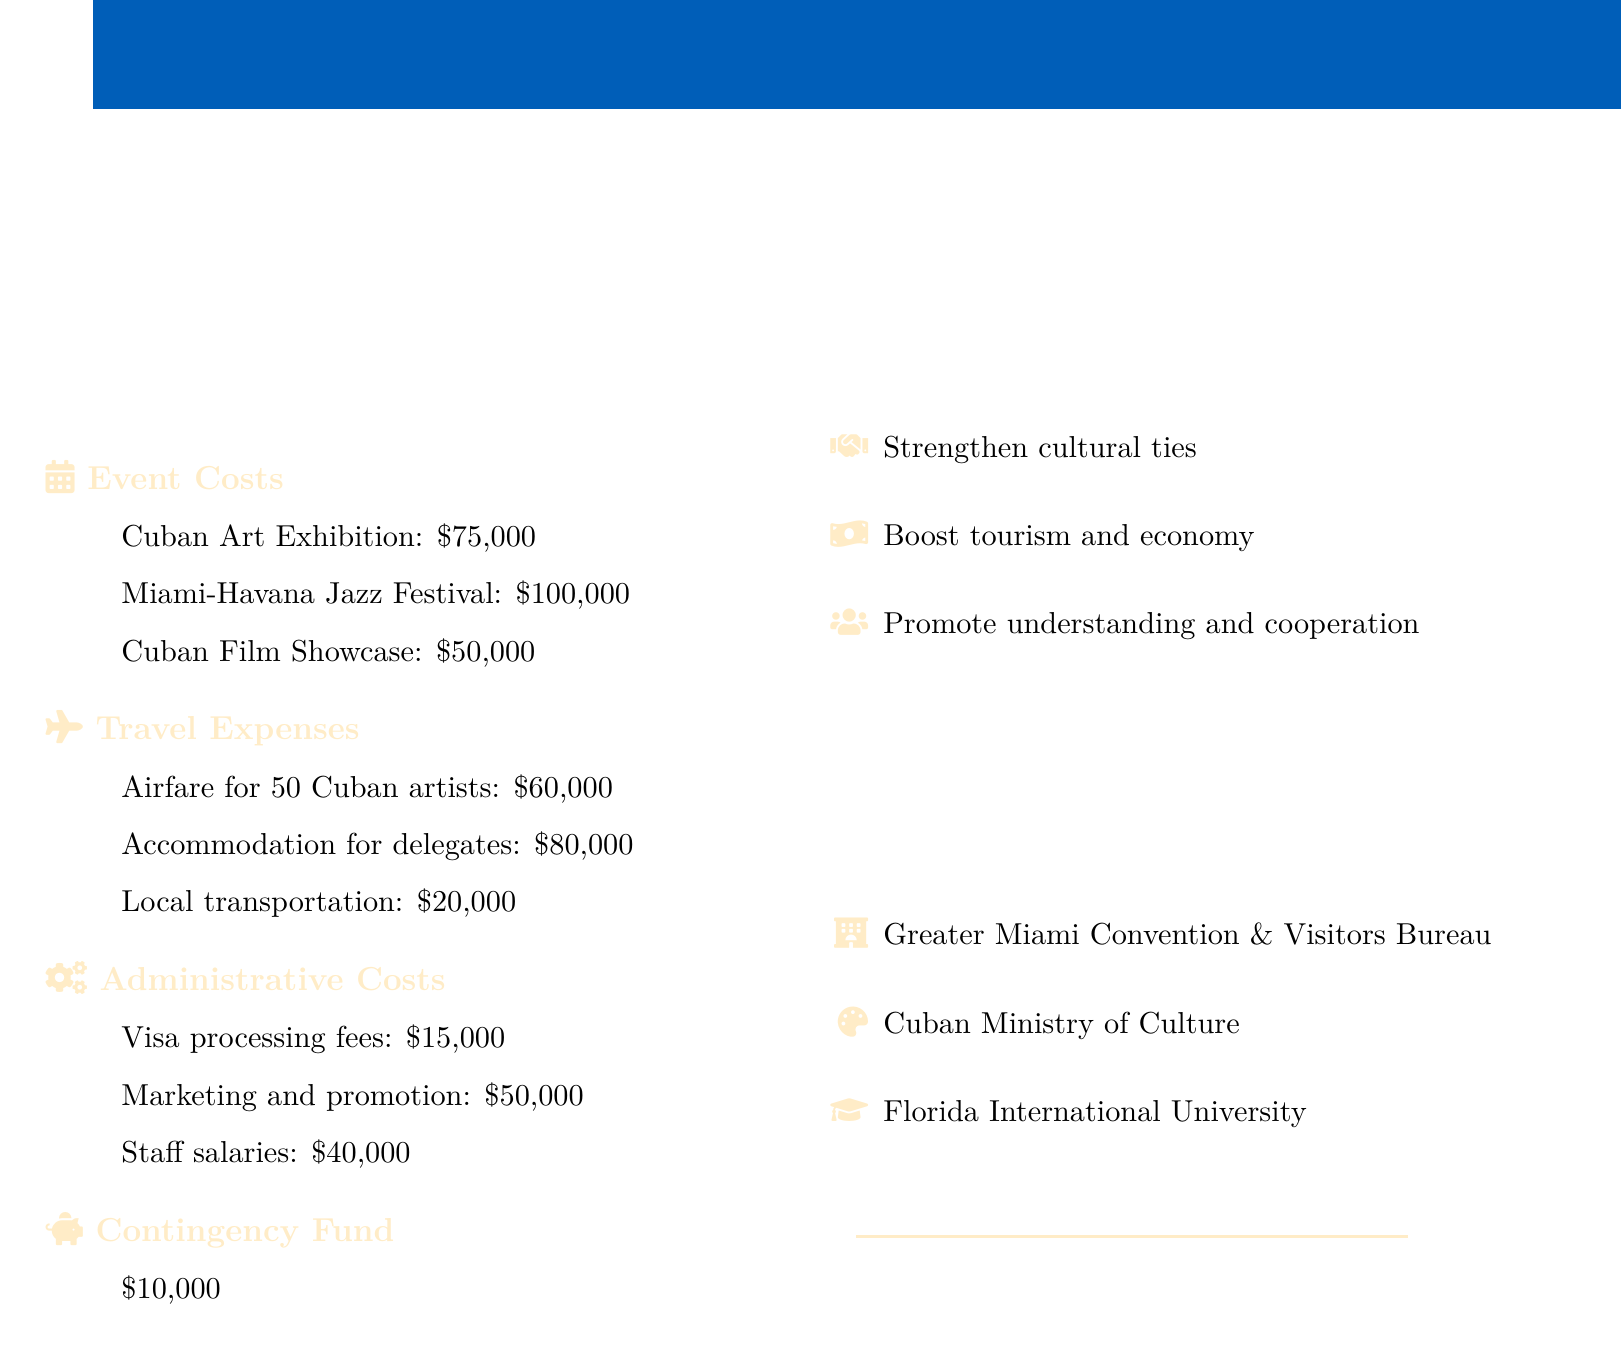What is the total budget? The total budget is listed at the top of the document as the overall budget allocation for the program.
Answer: $500,000 How much is allocated for the Cuban Art Exhibition? This is a specific event cost that is detailed under the Event Costs section.
Answer: $75,000 What is the cost for local transportation? Local transportation costs are mentioned under Travel Expenses, which is a specific part of the budget.
Answer: $20,000 What are the expected outcomes of the program? Expected outcomes are listed to outline the benefits anticipated from the budget proposal.
Answer: Strengthen cultural ties What is the contingency fund amount? The contingency fund is specified as a separate line item in the budget, showing the reserved funds.
Answer: $10,000 How many Cuban artists' airfares are covered? The number of Cuban artists included in the travel expenses is mentioned specifically under Travel Expenses.
Answer: 50 Which organization is a partnering organization? Partnering organizations are provided as part of the initiative; one example is the Greater Miami Convention & Visitors Bureau.
Answer: Greater Miami Convention & Visitors Bureau What percentage of the budget is allocated for the Miami-Havana Jazz Festival? This requires calculating based on the total budget and the specific event cost listed.
Answer: 20% What are the administrative costs in total? The administrative costs are listed individually, and the total needs to be calculated by adding them together.
Answer: $105,000 